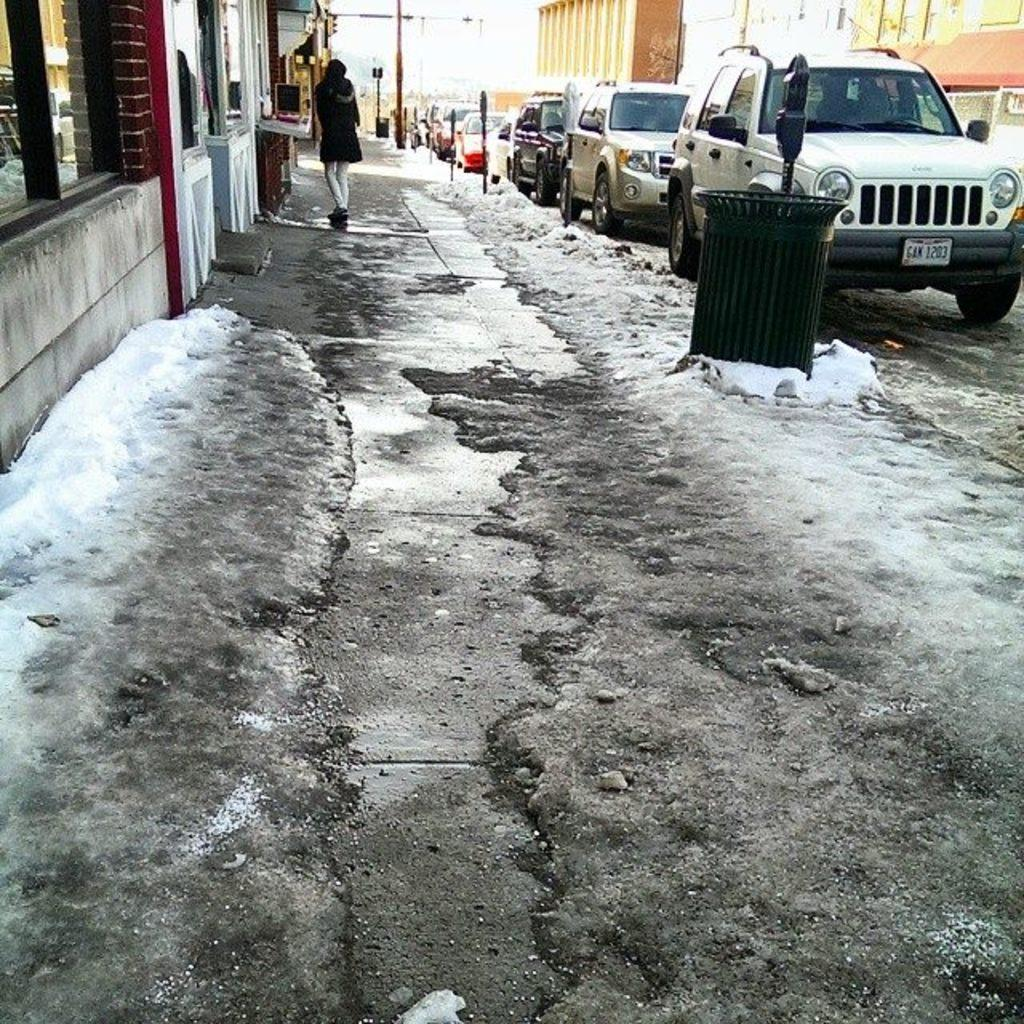What is located in the foreground of the image? There is ice in the foreground of the image. What can be seen in the background of the image? There are vehicles, poles, buildings, and a person in the background of the image. What type of question can be seen falling from the sky in the image? There is no question visible in the image, nor is there any indication of something falling from the sky. 